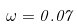Convert formula to latex. <formula><loc_0><loc_0><loc_500><loc_500>\omega = 0 . 0 7</formula> 